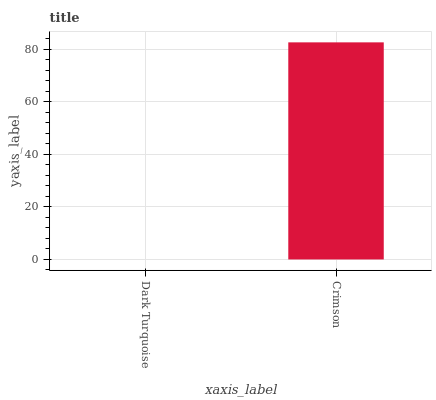Is Dark Turquoise the minimum?
Answer yes or no. Yes. Is Crimson the maximum?
Answer yes or no. Yes. Is Crimson the minimum?
Answer yes or no. No. Is Crimson greater than Dark Turquoise?
Answer yes or no. Yes. Is Dark Turquoise less than Crimson?
Answer yes or no. Yes. Is Dark Turquoise greater than Crimson?
Answer yes or no. No. Is Crimson less than Dark Turquoise?
Answer yes or no. No. Is Crimson the high median?
Answer yes or no. Yes. Is Dark Turquoise the low median?
Answer yes or no. Yes. Is Dark Turquoise the high median?
Answer yes or no. No. Is Crimson the low median?
Answer yes or no. No. 